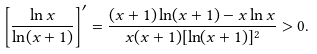<formula> <loc_0><loc_0><loc_500><loc_500>\left [ \frac { \ln x } { \ln ( x + 1 ) } \right ] ^ { \prime } = \frac { ( x + 1 ) \ln ( x + 1 ) - x \ln x } { x ( x + 1 ) [ \ln ( x + 1 ) ] ^ { 2 } } > 0 .</formula> 